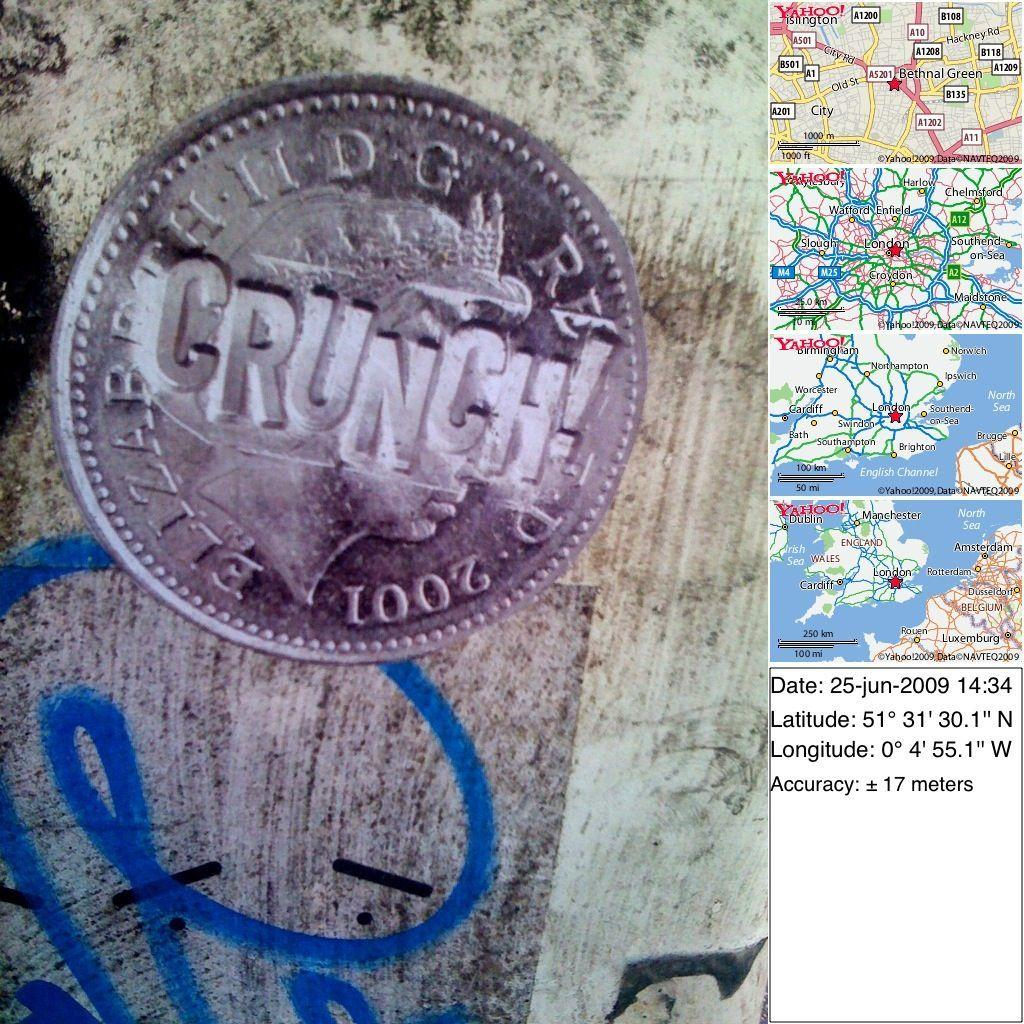<image>
Create a compact narrative representing the image presented. A coin with the word Crunch on it next to maps. 